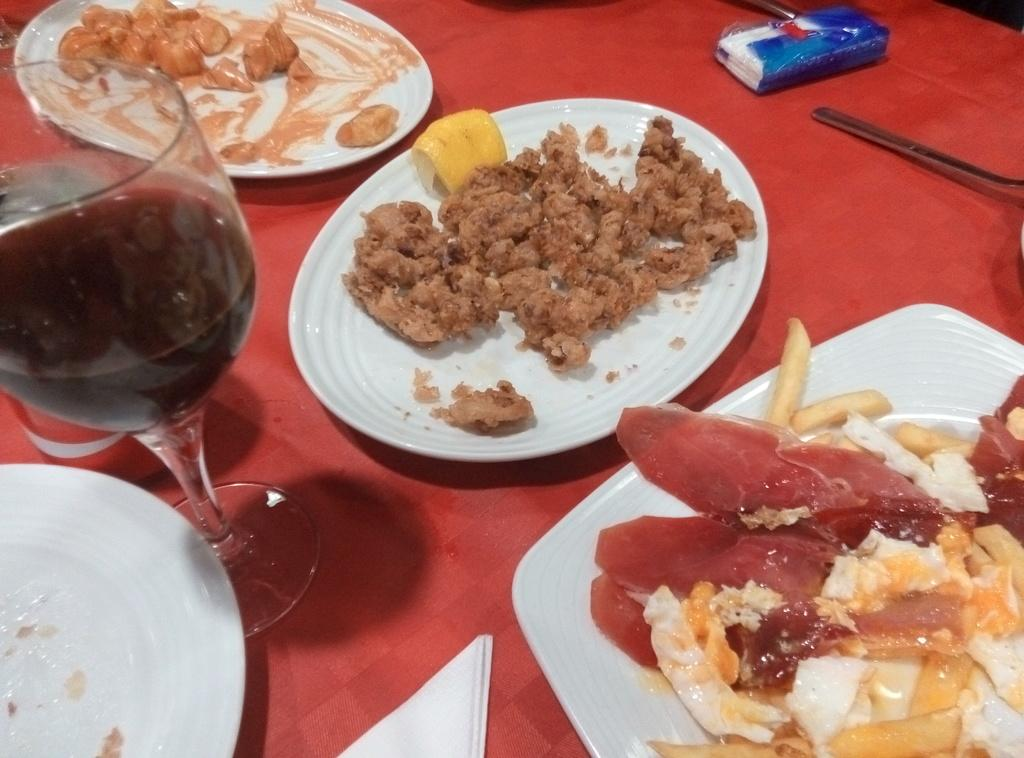What can be seen on the plates in the image? There are plates with food items in the image. What is in the glass that is visible in the image? There is a glass with a drink in the image. Where are the plates and glass located in the image? The plates and glass are placed on a platform. How many parents are visible in the image? There are no parents present in the image. Can you tell me the color of the kitten in the image? There is no kitten present in the image. 